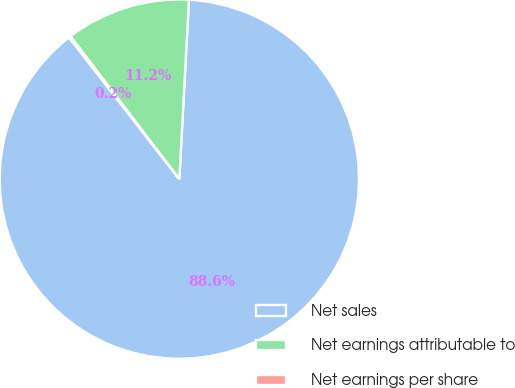<chart> <loc_0><loc_0><loc_500><loc_500><pie_chart><fcel>Net sales<fcel>Net earnings attributable to<fcel>Net earnings per share<nl><fcel>88.62%<fcel>11.22%<fcel>0.16%<nl></chart> 